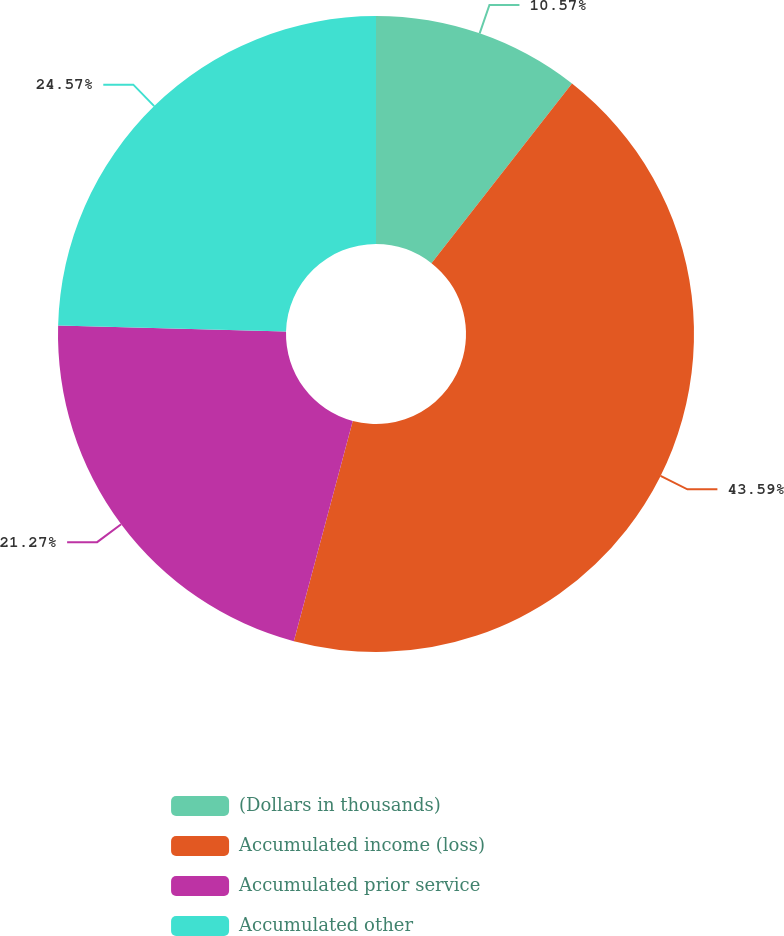<chart> <loc_0><loc_0><loc_500><loc_500><pie_chart><fcel>(Dollars in thousands)<fcel>Accumulated income (loss)<fcel>Accumulated prior service<fcel>Accumulated other<nl><fcel>10.57%<fcel>43.59%<fcel>21.27%<fcel>24.57%<nl></chart> 